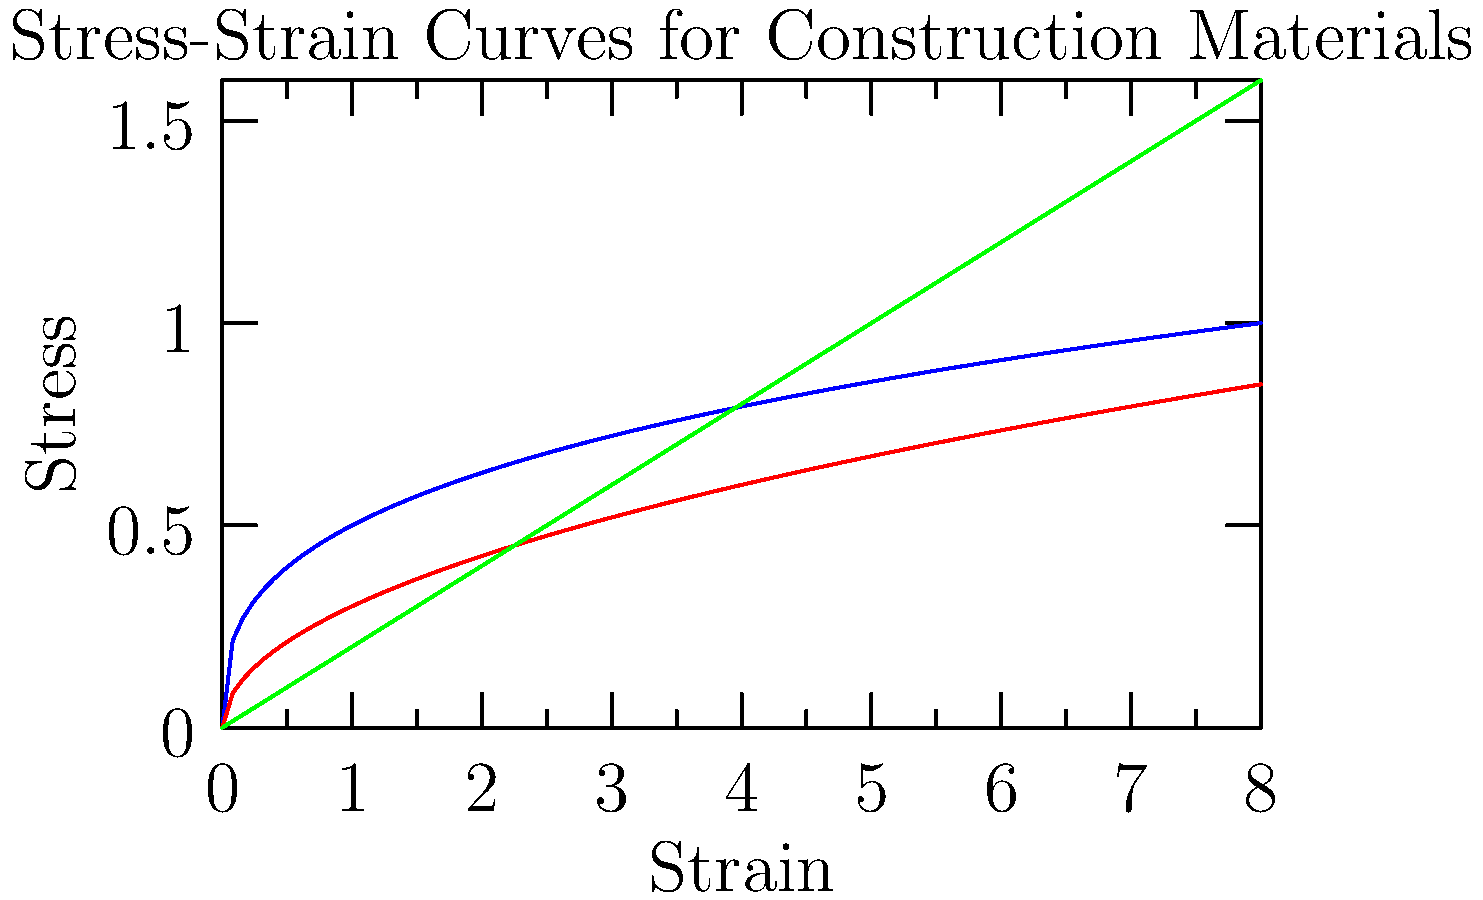Based on the stress-strain curves shown for steel, concrete, and aluminum, which material would be most suitable for a structure that needs to withstand high stress with minimal deformation? To determine the most suitable material for a structure that needs to withstand high stress with minimal deformation, we need to analyze the stress-strain curves:

1. Steel (blue curve):
   - Shows a steep initial slope, indicating high stiffness.
   - Has a high yield point before plastic deformation occurs.

2. Concrete (red curve):
   - Has a moderate slope, indicating less stiffness than steel.
   - Shows a non-linear relationship between stress and strain.

3. Aluminum (green curve):
   - Has the lowest slope among the three materials, indicating the least stiffness.
   - Shows a linear relationship between stress and strain.

The steeper the slope of the stress-strain curve, the higher the material's stiffness. A steeper slope means that the material can withstand higher stress with less deformation.

Steel has the steepest initial slope, indicating it has the highest stiffness among the three materials. This means that steel can withstand the highest stress with the least amount of deformation in the elastic region.

Additionally, steel's high yield point allows it to maintain its elastic properties under higher stress compared to concrete and aluminum.
Answer: Steel 